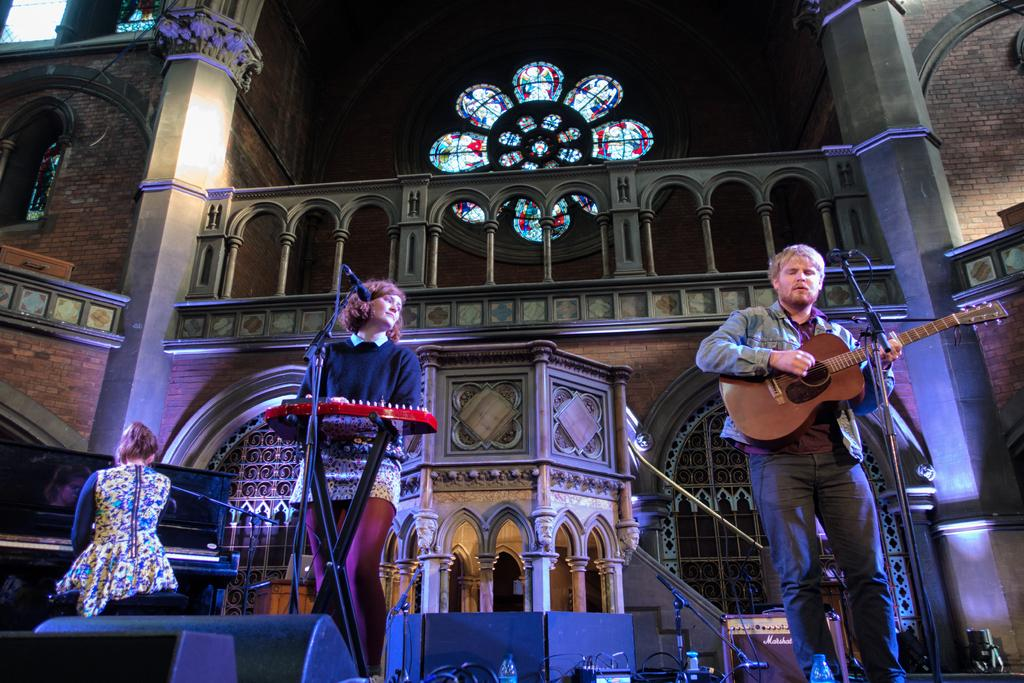How many people are in the image? There are three persons in the image. What are the persons doing in the image? The persons are playing musical instruments. What can be seen in the background of the image? There is a building in the background of the image. How many cats are sitting on the roof of the building in the image? There are no cats present in the image; it only features three persons playing musical instruments and a building in the background. 